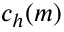<formula> <loc_0><loc_0><loc_500><loc_500>c _ { h } ( m )</formula> 